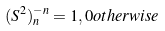<formula> <loc_0><loc_0><loc_500><loc_500>( S ^ { 2 } ) _ { n } ^ { - n } = 1 , 0 o t h e r w i s e</formula> 